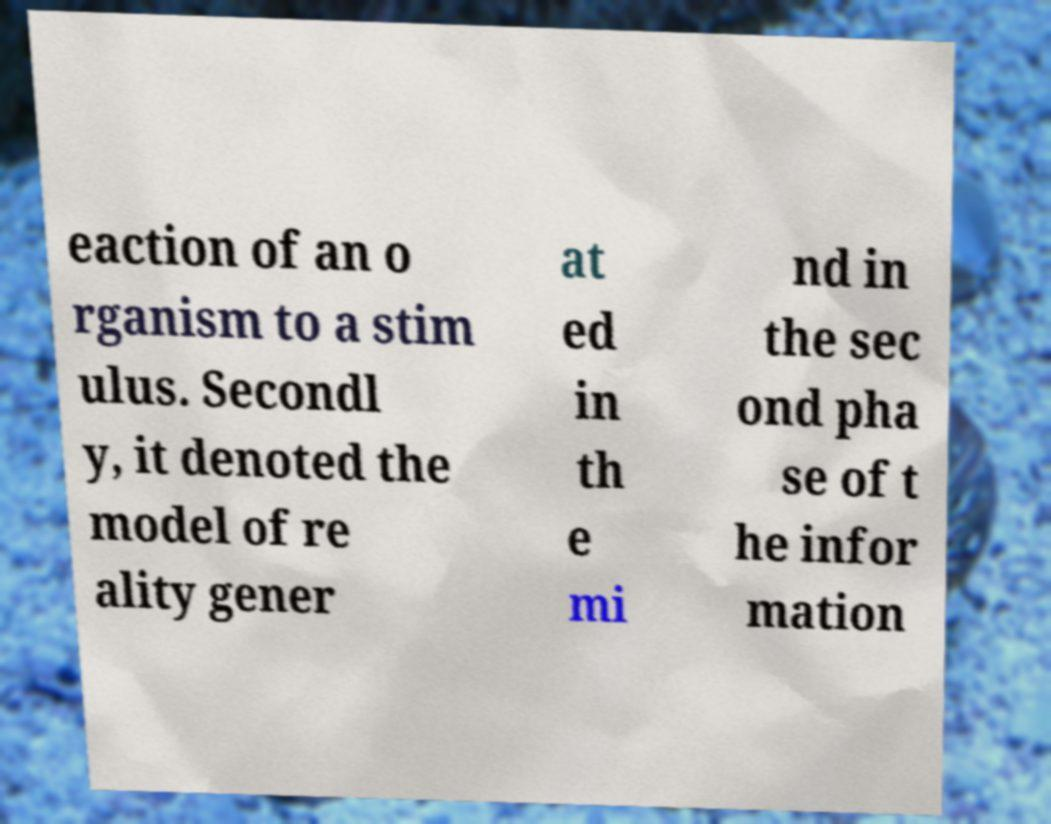I need the written content from this picture converted into text. Can you do that? eaction of an o rganism to a stim ulus. Secondl y, it denoted the model of re ality gener at ed in th e mi nd in the sec ond pha se of t he infor mation 